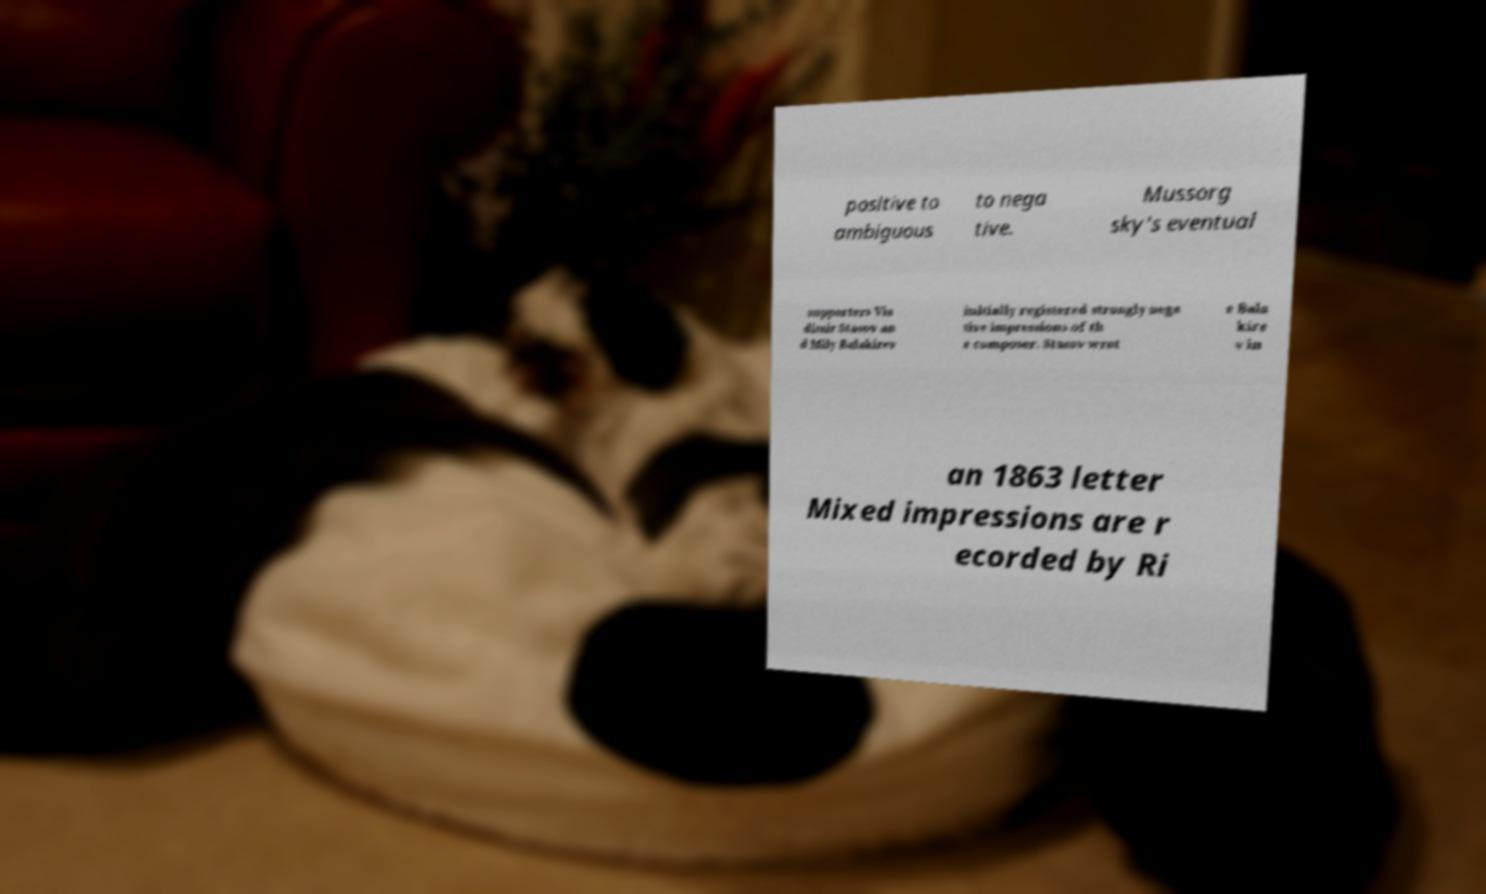Could you extract and type out the text from this image? positive to ambiguous to nega tive. Mussorg sky's eventual supporters Vla dimir Stasov an d Mily Balakirev initially registered strongly nega tive impressions of th e composer. Stasov wrot e Bala kire v in an 1863 letter Mixed impressions are r ecorded by Ri 